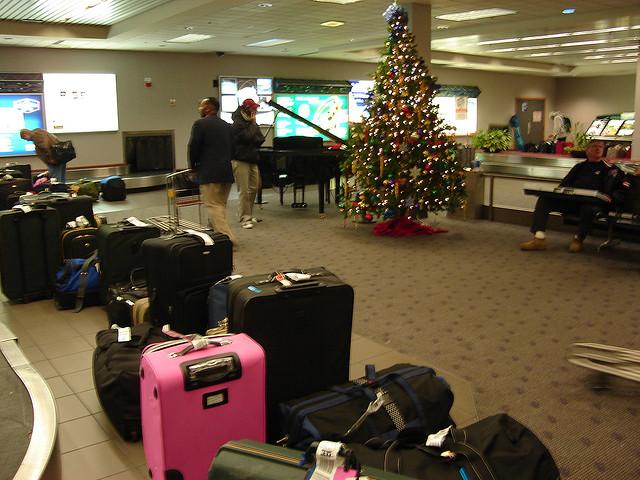Why are the suitcases tied?
Short answer required. For security. How many red tags?
Keep it brief. 0. Which piece of luggage stands out from the others?
Give a very brief answer. Pink. Is this taken in the airport?
Keep it brief. Yes. Is that a Christmas tree?
Answer briefly. Yes. 